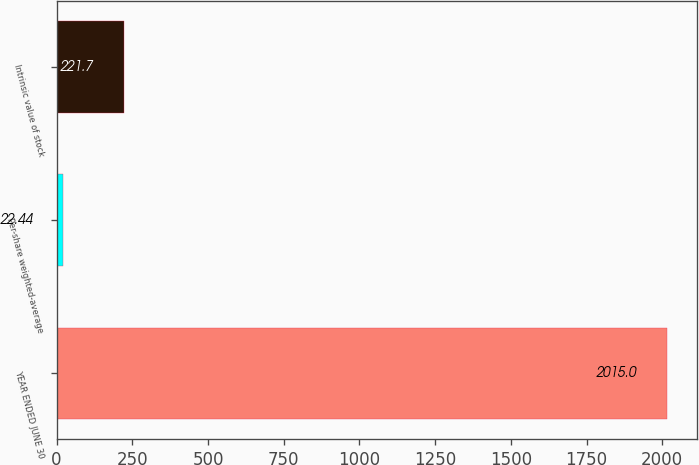<chart> <loc_0><loc_0><loc_500><loc_500><bar_chart><fcel>YEAR ENDED JUNE 30<fcel>Per-share weighted-average<fcel>Intrinsic value of stock<nl><fcel>2015<fcel>22.44<fcel>221.7<nl></chart> 